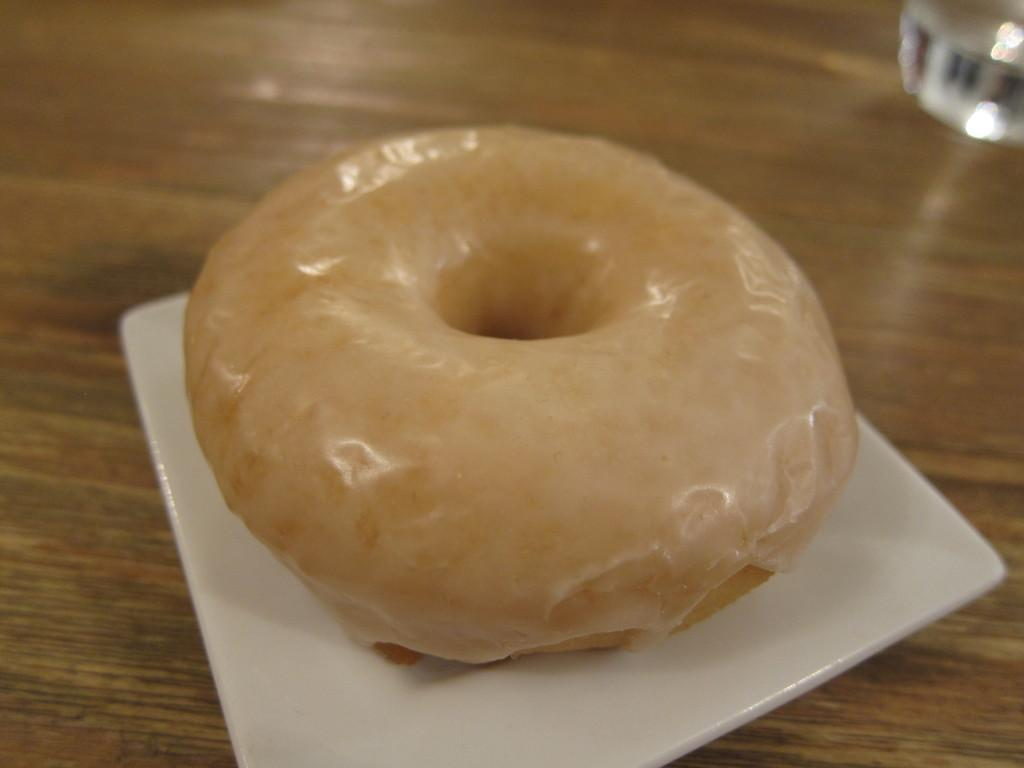What is present on the plate in the image? There is food on the plate in the image. What can be said about the color of the plate? The plate is white in color. On what surface is the plate placed? The plate is on a brown surface. What type of stamp can be seen on the food in the image? There is no stamp present on the food in the image. How many bats are visible in the image? There are no bats present in the image. 